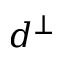<formula> <loc_0><loc_0><loc_500><loc_500>d ^ { \perp }</formula> 